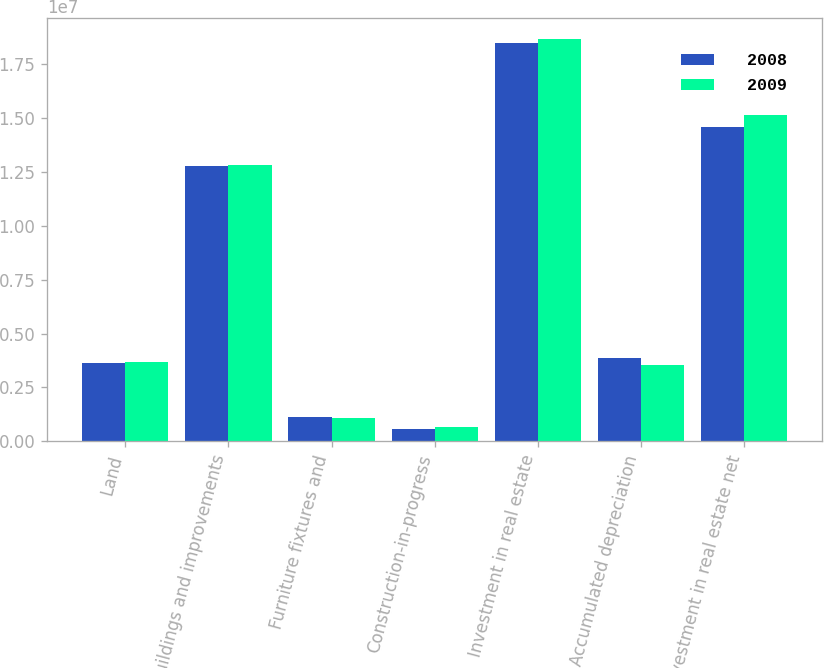Convert chart to OTSL. <chart><loc_0><loc_0><loc_500><loc_500><stacked_bar_chart><ecel><fcel>Land<fcel>Buildings and improvements<fcel>Furniture fixtures and<fcel>Construction-in-progress<fcel>Investment in real estate<fcel>Accumulated depreciation<fcel>Investment in real estate net<nl><fcel>2008<fcel>3.65032e+06<fcel>1.27815e+07<fcel>1.11198e+06<fcel>562263<fcel>1.84651e+07<fcel>3.87756e+06<fcel>1.45876e+07<nl><fcel>2009<fcel>3.6713e+06<fcel>1.28363e+07<fcel>1.07228e+06<fcel>680118<fcel>1.86902e+07<fcel>3.5613e+06<fcel>1.51289e+07<nl></chart> 